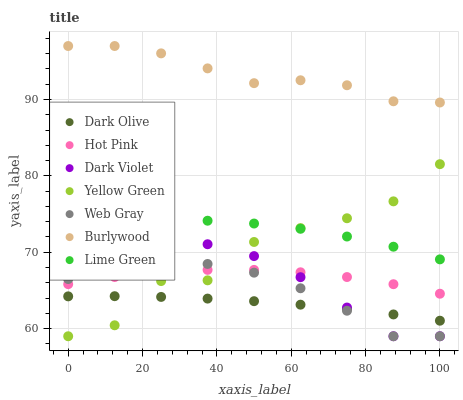Does Dark Olive have the minimum area under the curve?
Answer yes or no. Yes. Does Burlywood have the maximum area under the curve?
Answer yes or no. Yes. Does Yellow Green have the minimum area under the curve?
Answer yes or no. No. Does Yellow Green have the maximum area under the curve?
Answer yes or no. No. Is Dark Olive the smoothest?
Answer yes or no. Yes. Is Yellow Green the roughest?
Answer yes or no. Yes. Is Burlywood the smoothest?
Answer yes or no. No. Is Burlywood the roughest?
Answer yes or no. No. Does Web Gray have the lowest value?
Answer yes or no. Yes. Does Burlywood have the lowest value?
Answer yes or no. No. Does Burlywood have the highest value?
Answer yes or no. Yes. Does Yellow Green have the highest value?
Answer yes or no. No. Is Hot Pink less than Lime Green?
Answer yes or no. Yes. Is Burlywood greater than Web Gray?
Answer yes or no. Yes. Does Web Gray intersect Dark Olive?
Answer yes or no. Yes. Is Web Gray less than Dark Olive?
Answer yes or no. No. Is Web Gray greater than Dark Olive?
Answer yes or no. No. Does Hot Pink intersect Lime Green?
Answer yes or no. No. 